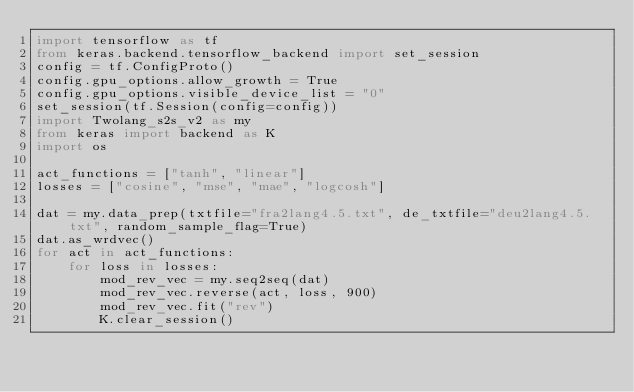<code> <loc_0><loc_0><loc_500><loc_500><_Python_>import tensorflow as tf
from keras.backend.tensorflow_backend import set_session
config = tf.ConfigProto()
config.gpu_options.allow_growth = True
config.gpu_options.visible_device_list = "0"
set_session(tf.Session(config=config))
import Twolang_s2s_v2 as my
from keras import backend as K
import os

act_functions = ["tanh", "linear"]
losses = ["cosine", "mse", "mae", "logcosh"]

dat = my.data_prep(txtfile="fra2lang4.5.txt", de_txtfile="deu2lang4.5.txt", random_sample_flag=True)
dat.as_wrdvec()
for act in act_functions:
    for loss in losses:
        mod_rev_vec = my.seq2seq(dat)
        mod_rev_vec.reverse(act, loss, 900)
        mod_rev_vec.fit("rev")
        K.clear_session()
</code> 